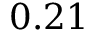Convert formula to latex. <formula><loc_0><loc_0><loc_500><loc_500>0 . 2 1</formula> 